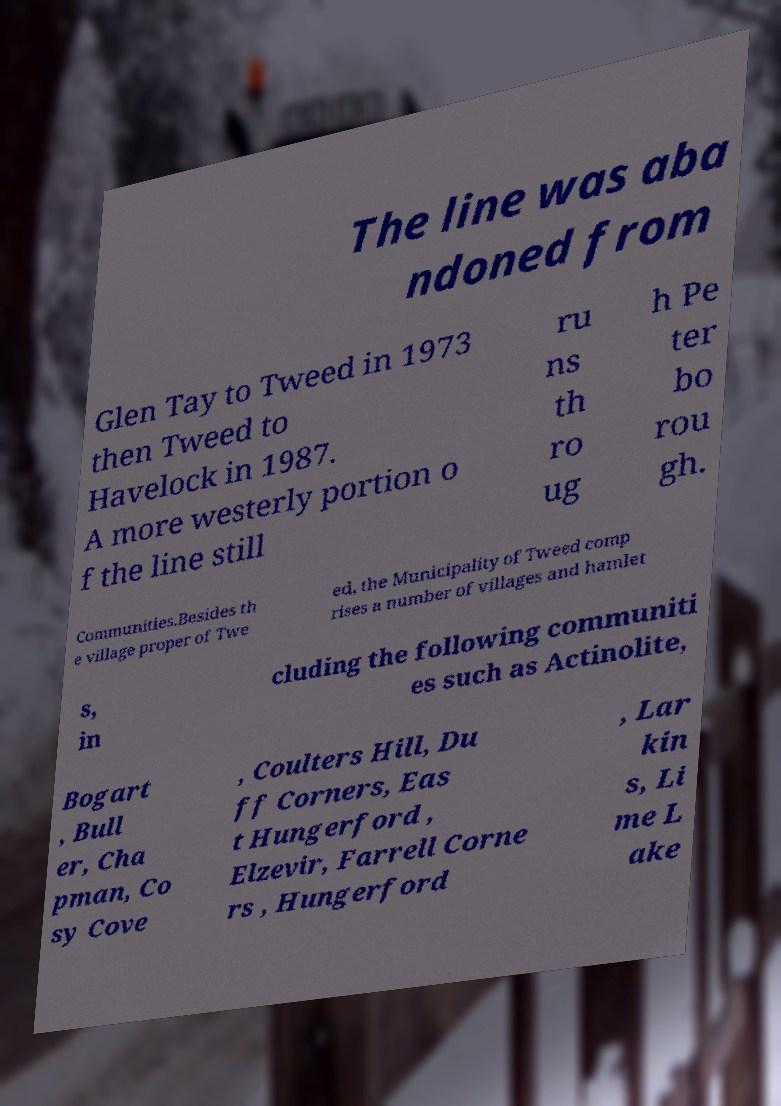Can you accurately transcribe the text from the provided image for me? The line was aba ndoned from Glen Tay to Tweed in 1973 then Tweed to Havelock in 1987. A more westerly portion o f the line still ru ns th ro ug h Pe ter bo rou gh. Communities.Besides th e village proper of Twe ed, the Municipality of Tweed comp rises a number of villages and hamlet s, in cluding the following communiti es such as Actinolite, Bogart , Bull er, Cha pman, Co sy Cove , Coulters Hill, Du ff Corners, Eas t Hungerford , Elzevir, Farrell Corne rs , Hungerford , Lar kin s, Li me L ake 